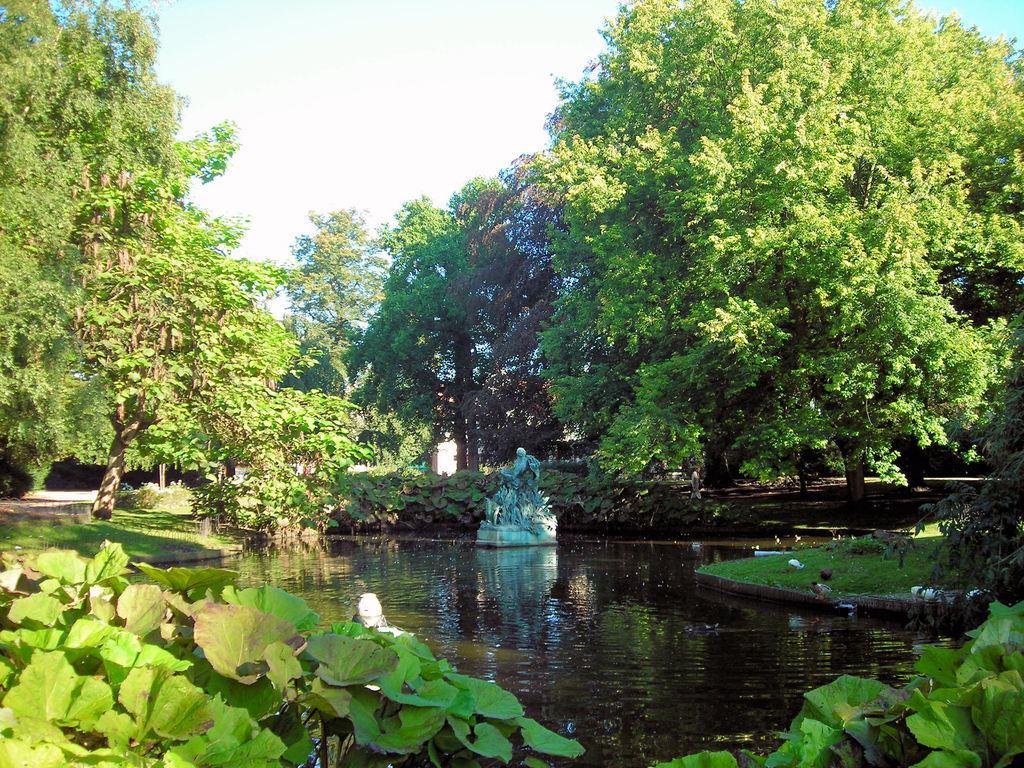How would you summarize this image in a sentence or two? In the center of the image there is a fountain in the pond. In the background there are many trees and sky. In the foreground we can see grass and plants. 